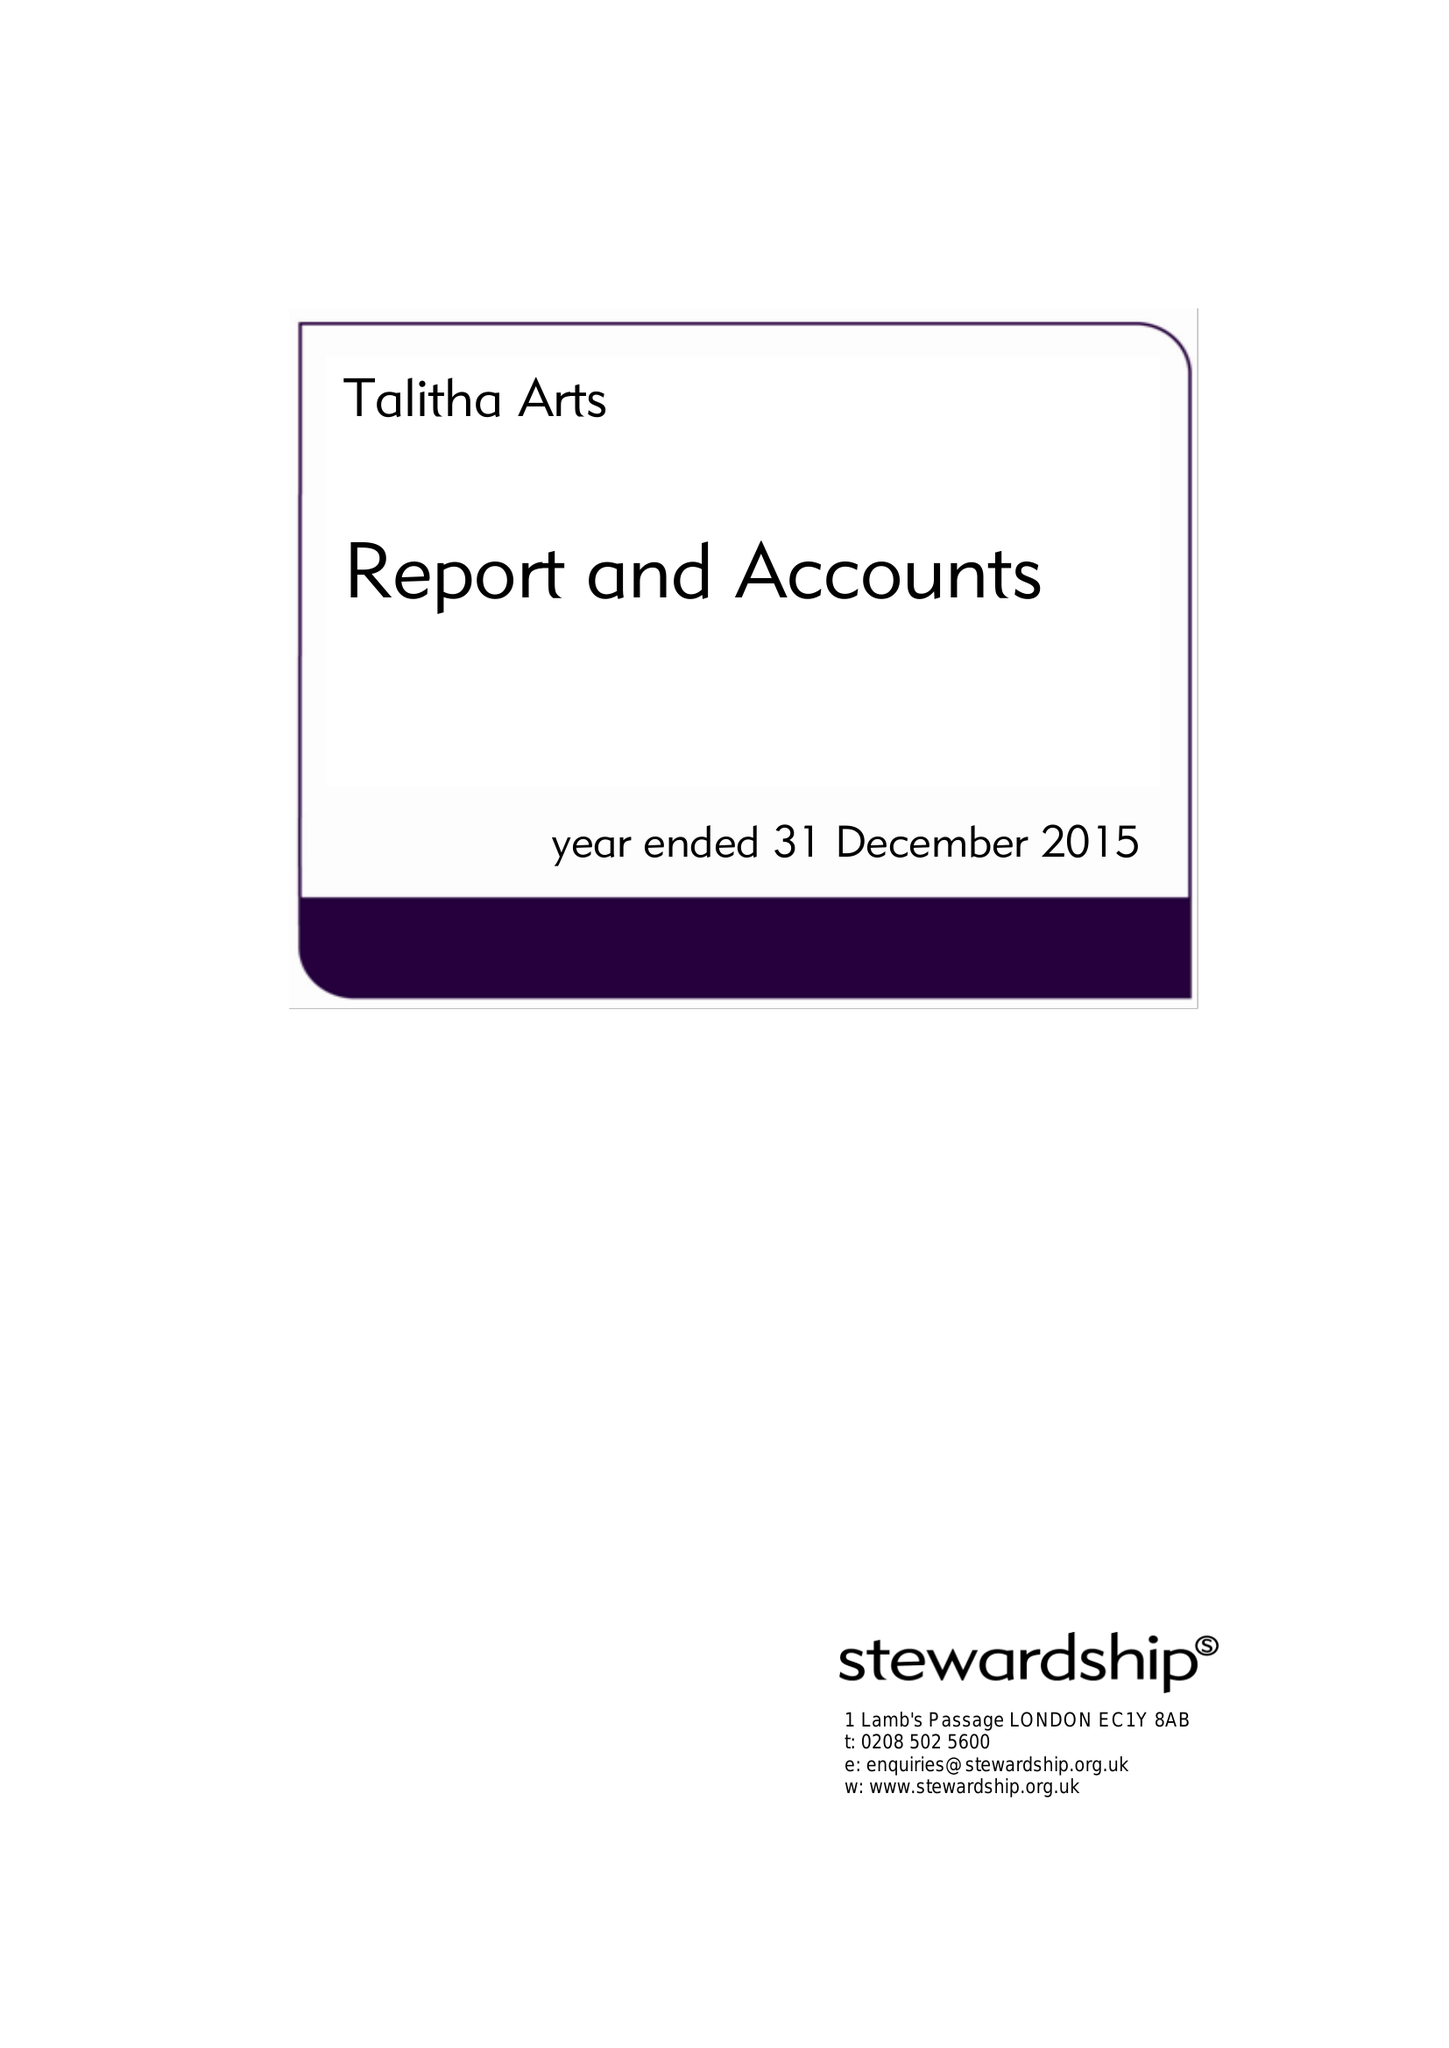What is the value for the report_date?
Answer the question using a single word or phrase. 2015-12-31 